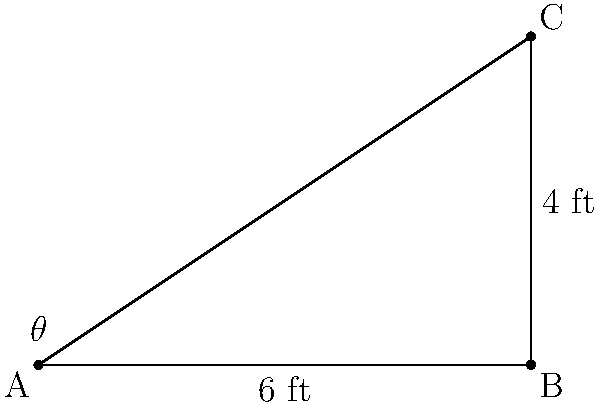You're designing a trellis structure for your climbing vegetables. The base of the trellis is 6 feet wide, and you want it to reach a height of 4 feet. What angle (θ) should the trellis make with the ground to achieve this height? To find the angle θ, we can use the trigonometric function tangent (tan). Here's how:

1) In the right triangle ABC, we know:
   - The adjacent side (base) = 6 feet
   - The opposite side (height) = 4 feet

2) The tangent of an angle is defined as the ratio of the opposite side to the adjacent side:

   $$\tan(\theta) = \frac{\text{opposite}}{\text{adjacent}} = \frac{\text{height}}{\text{base}}$$

3) Substituting our known values:

   $$\tan(\theta) = \frac{4}{6} = \frac{2}{3}$$

4) To find θ, we need to use the inverse tangent function (arctan or tan^(-1)):

   $$\theta = \arctan(\frac{2}{3})$$

5) Using a calculator or trigonometric tables:

   $$\theta \approx 33.69^\circ$$

Therefore, the trellis should make an angle of approximately 33.69° with the ground.
Answer: $33.69^\circ$ 